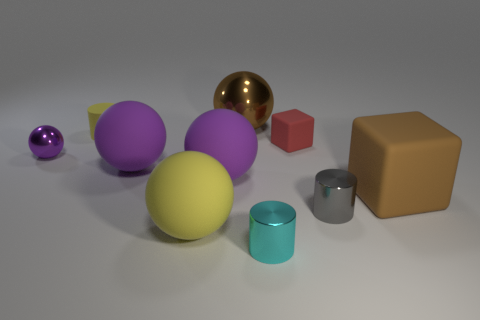Subtract all metallic spheres. How many spheres are left? 3 Subtract all yellow spheres. How many spheres are left? 4 Subtract all cubes. How many objects are left? 8 Subtract 1 blocks. How many blocks are left? 1 Subtract all gray cylinders. How many brown blocks are left? 1 Add 5 gray objects. How many gray objects are left? 6 Add 4 large brown metallic balls. How many large brown metallic balls exist? 5 Subtract 1 brown balls. How many objects are left? 9 Subtract all green blocks. Subtract all green cylinders. How many blocks are left? 2 Subtract all gray cylinders. Subtract all small cyan cylinders. How many objects are left? 8 